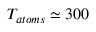<formula> <loc_0><loc_0><loc_500><loc_500>T _ { a t o m s } \simeq 3 0 0</formula> 